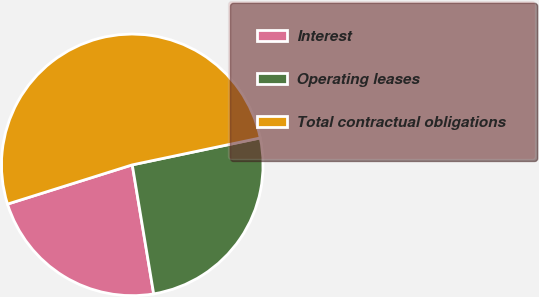<chart> <loc_0><loc_0><loc_500><loc_500><pie_chart><fcel>Interest<fcel>Operating leases<fcel>Total contractual obligations<nl><fcel>22.77%<fcel>25.68%<fcel>51.55%<nl></chart> 